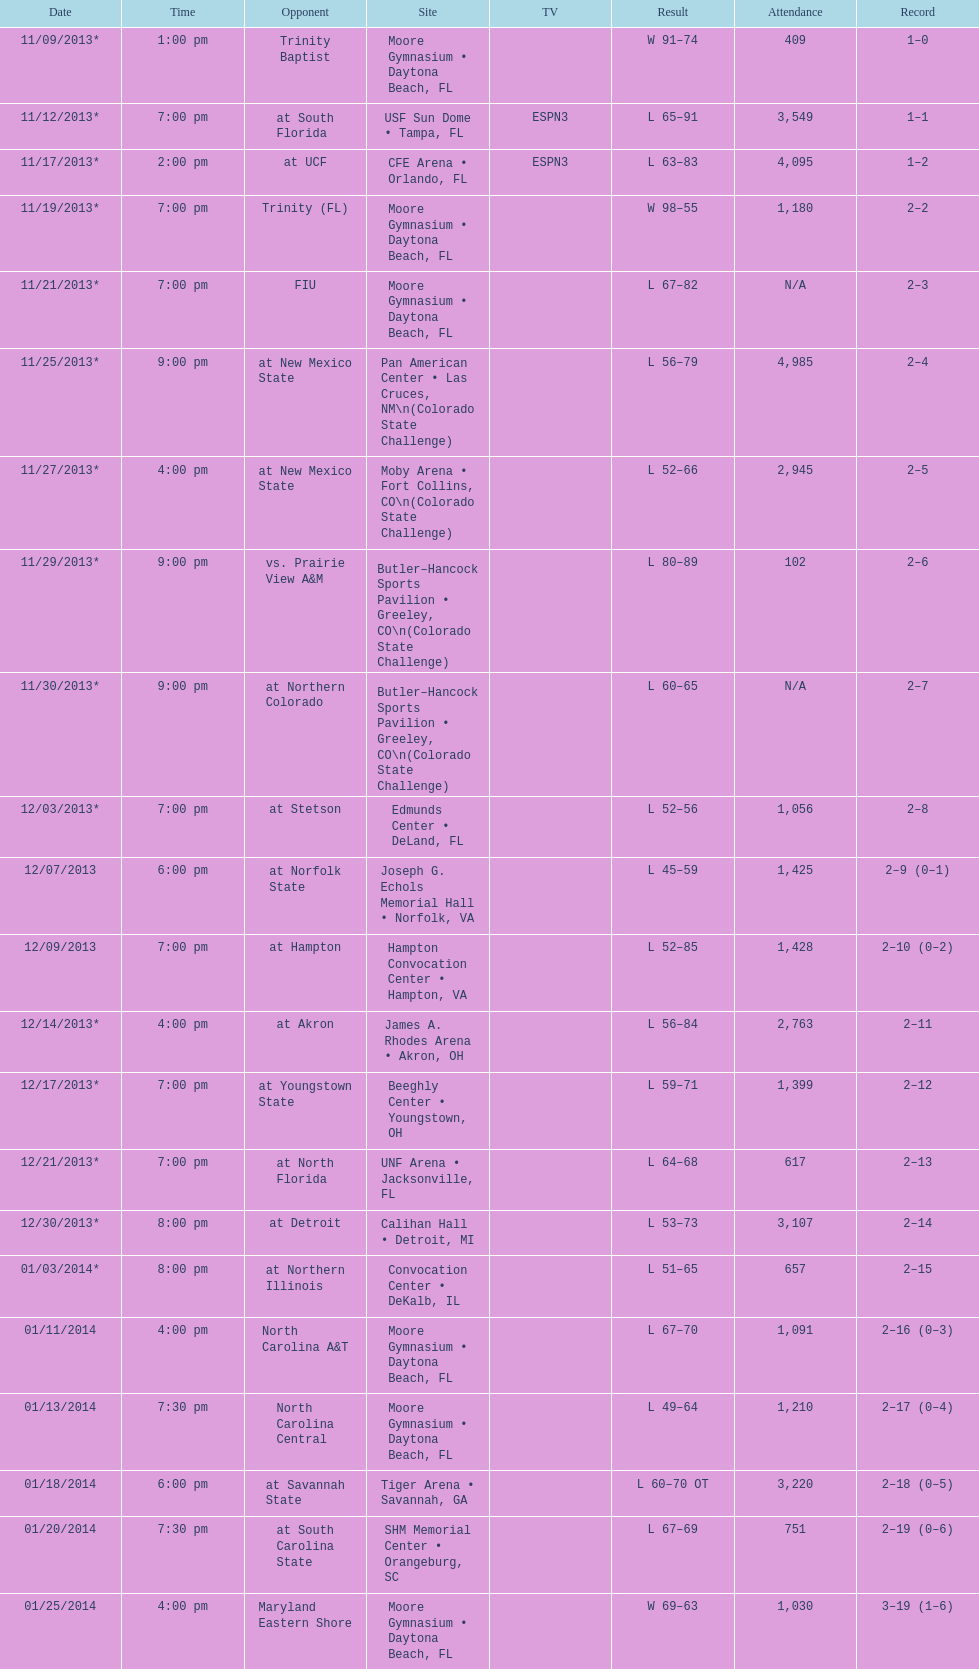In which game was the winning difference greater, against trinity (fl) or against trinity baptist? Trinity (FL). Parse the table in full. {'header': ['Date', 'Time', 'Opponent', 'Site', 'TV', 'Result', 'Attendance', 'Record'], 'rows': [['11/09/2013*', '1:00 pm', 'Trinity Baptist', 'Moore Gymnasium • Daytona Beach, FL', '', 'W\xa091–74', '409', '1–0'], ['11/12/2013*', '7:00 pm', 'at\xa0South Florida', 'USF Sun Dome • Tampa, FL', 'ESPN3', 'L\xa065–91', '3,549', '1–1'], ['11/17/2013*', '2:00 pm', 'at\xa0UCF', 'CFE Arena • Orlando, FL', 'ESPN3', 'L\xa063–83', '4,095', '1–2'], ['11/19/2013*', '7:00 pm', 'Trinity (FL)', 'Moore Gymnasium • Daytona Beach, FL', '', 'W\xa098–55', '1,180', '2–2'], ['11/21/2013*', '7:00 pm', 'FIU', 'Moore Gymnasium • Daytona Beach, FL', '', 'L\xa067–82', 'N/A', '2–3'], ['11/25/2013*', '9:00 pm', 'at\xa0New Mexico State', 'Pan American Center • Las Cruces, NM\\n(Colorado State Challenge)', '', 'L\xa056–79', '4,985', '2–4'], ['11/27/2013*', '4:00 pm', 'at\xa0New Mexico State', 'Moby Arena • Fort Collins, CO\\n(Colorado State Challenge)', '', 'L\xa052–66', '2,945', '2–5'], ['11/29/2013*', '9:00 pm', 'vs.\xa0Prairie View A&M', 'Butler–Hancock Sports Pavilion • Greeley, CO\\n(Colorado State Challenge)', '', 'L\xa080–89', '102', '2–6'], ['11/30/2013*', '9:00 pm', 'at\xa0Northern Colorado', 'Butler–Hancock Sports Pavilion • Greeley, CO\\n(Colorado State Challenge)', '', 'L\xa060–65', 'N/A', '2–7'], ['12/03/2013*', '7:00 pm', 'at\xa0Stetson', 'Edmunds Center • DeLand, FL', '', 'L\xa052–56', '1,056', '2–8'], ['12/07/2013', '6:00 pm', 'at\xa0Norfolk State', 'Joseph G. Echols Memorial Hall • Norfolk, VA', '', 'L\xa045–59', '1,425', '2–9 (0–1)'], ['12/09/2013', '7:00 pm', 'at\xa0Hampton', 'Hampton Convocation Center • Hampton, VA', '', 'L\xa052–85', '1,428', '2–10 (0–2)'], ['12/14/2013*', '4:00 pm', 'at\xa0Akron', 'James A. Rhodes Arena • Akron, OH', '', 'L\xa056–84', '2,763', '2–11'], ['12/17/2013*', '7:00 pm', 'at\xa0Youngstown State', 'Beeghly Center • Youngstown, OH', '', 'L\xa059–71', '1,399', '2–12'], ['12/21/2013*', '7:00 pm', 'at\xa0North Florida', 'UNF Arena • Jacksonville, FL', '', 'L\xa064–68', '617', '2–13'], ['12/30/2013*', '8:00 pm', 'at\xa0Detroit', 'Calihan Hall • Detroit, MI', '', 'L\xa053–73', '3,107', '2–14'], ['01/03/2014*', '8:00 pm', 'at\xa0Northern Illinois', 'Convocation Center • DeKalb, IL', '', 'L\xa051–65', '657', '2–15'], ['01/11/2014', '4:00 pm', 'North Carolina A&T', 'Moore Gymnasium • Daytona Beach, FL', '', 'L\xa067–70', '1,091', '2–16 (0–3)'], ['01/13/2014', '7:30 pm', 'North Carolina Central', 'Moore Gymnasium • Daytona Beach, FL', '', 'L\xa049–64', '1,210', '2–17 (0–4)'], ['01/18/2014', '6:00 pm', 'at\xa0Savannah State', 'Tiger Arena • Savannah, GA', '', 'L\xa060–70\xa0OT', '3,220', '2–18 (0–5)'], ['01/20/2014', '7:30 pm', 'at\xa0South Carolina State', 'SHM Memorial Center • Orangeburg, SC', '', 'L\xa067–69', '751', '2–19 (0–6)'], ['01/25/2014', '4:00 pm', 'Maryland Eastern Shore', 'Moore Gymnasium • Daytona Beach, FL', '', 'W\xa069–63', '1,030', '3–19 (1–6)'], ['01/27/2014', '7:30 pm', 'Howard', 'Moore Gymnasium • Daytona Beach, FL', '', 'W\xa058–47', '1,216', '4–19 (2–6)'], ['02/01/2014', '4:00 pm', 'Savannah State', 'Moore Gymnasium • Daytona Beach, FL', '', 'L\xa040–50', '1,075', '4–20 (2–7)'], ['02/03/2014', '7:30 pm', 'South Carolina State', 'Moore Gymnasium • Daytona Beach, FL', '', 'W\xa091–59', '1,063', '5–20 (3–7)'], ['02/08/2014', '4:00 pm', 'at\xa0North Carolina Central', 'McLendon–McDougald Gymnasium • Durham, NC', '', 'L\xa054–77', '2,420', '5–21 (3–8)'], ['02/10/2014', '8:00 pm', 'at\xa0North Carolina A&T', 'Corbett Sports Center • Greensboro, NC', '', 'W\xa072–71', '1,019', '6–21 (4–8)'], ['02/15/2014', '4:00 pm', 'Delaware State', 'Moore Gymnasium • Daytona Beach, FL', '', 'L\xa067–79', '843', '6–22 (4–9)'], ['02/22/2014', '4:00 pm', 'Florida A&M', 'Moore Gymnasium • Daytona Beach, FL', '', 'L\xa075–80', '3,231', '6–23 (4–10)'], ['03/01/2014', '4:00 pm', 'at\xa0Morgan State', 'Talmadge L. Hill Field House • Baltimore, MD', '', 'L\xa061–65', '2,056', '6–24 (4–11)'], ['03/06/2014', '7:30 pm', 'at\xa0Florida A&M', 'Teaching Gym • Tallahassee, FL', '', 'W\xa070–68', '2,376', '7–24 (5–11)'], ['03/11/2014', '6:30 pm', 'vs.\xa0Coppin State', 'Norfolk Scope • Norfolk, VA\\n(First round)', '', 'L\xa068–75', '4,658', '7–25']]} 